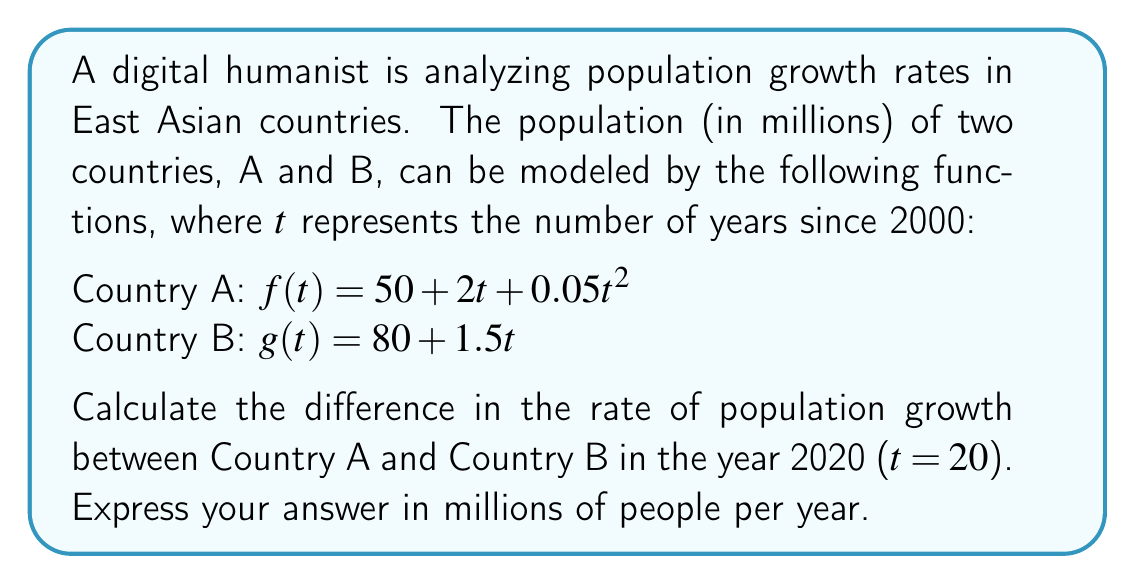Can you answer this question? To solve this problem, we need to follow these steps:

1. Find the rate of population growth for each country in 2020.
2. Calculate the difference between these rates.

For Country A:
The rate of population growth is given by the derivative of $f(t)$.
$$f'(t) = 2 + 0.1t$$
In 2020 (t = 20):
$$f'(20) = 2 + 0.1(20) = 2 + 2 = 4$$

For Country B:
The rate of population growth is given by the derivative of $g(t)$.
$$g'(t) = 1.5$$
This is constant for all years, including 2020.

Now, let's calculate the difference:
Difference = Rate of Country A - Rate of Country B
$$4 - 1.5 = 2.5$$

Therefore, in 2020, Country A's population is growing 2.5 million people per year faster than Country B's population.
Answer: 2.5 million people per year 